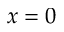<formula> <loc_0><loc_0><loc_500><loc_500>x = 0</formula> 